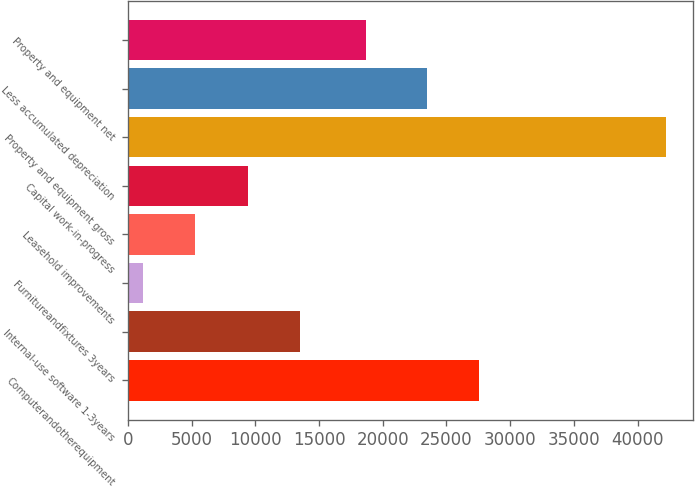Convert chart to OTSL. <chart><loc_0><loc_0><loc_500><loc_500><bar_chart><fcel>Computerandotherequipment<fcel>Internal-use software 1-3years<fcel>Furnitureandfixtures 3years<fcel>Leasehold improvements<fcel>Capital work-in-progress<fcel>Property and equipment gross<fcel>Less accumulated depreciation<fcel>Property and equipment net<nl><fcel>27578.2<fcel>13496.6<fcel>1193<fcel>5294.2<fcel>9395.4<fcel>42205<fcel>23477<fcel>18728<nl></chart> 